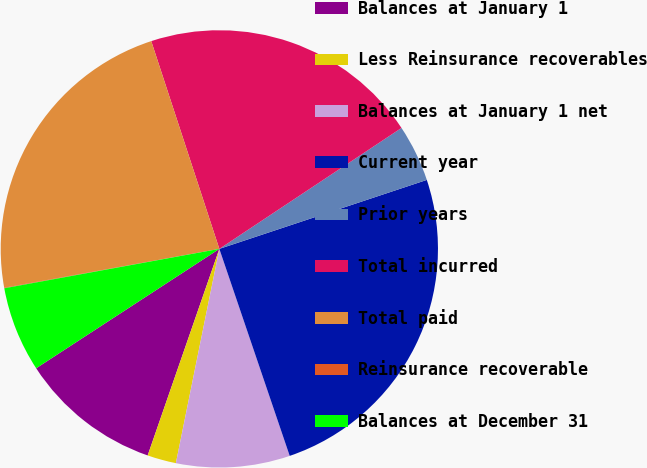Convert chart to OTSL. <chart><loc_0><loc_0><loc_500><loc_500><pie_chart><fcel>Balances at January 1<fcel>Less Reinsurance recoverables<fcel>Balances at January 1 net<fcel>Current year<fcel>Prior years<fcel>Total incurred<fcel>Total paid<fcel>Reinsurance recoverable<fcel>Balances at December 31<nl><fcel>10.49%<fcel>2.13%<fcel>8.4%<fcel>24.89%<fcel>4.22%<fcel>20.71%<fcel>22.8%<fcel>0.04%<fcel>6.31%<nl></chart> 